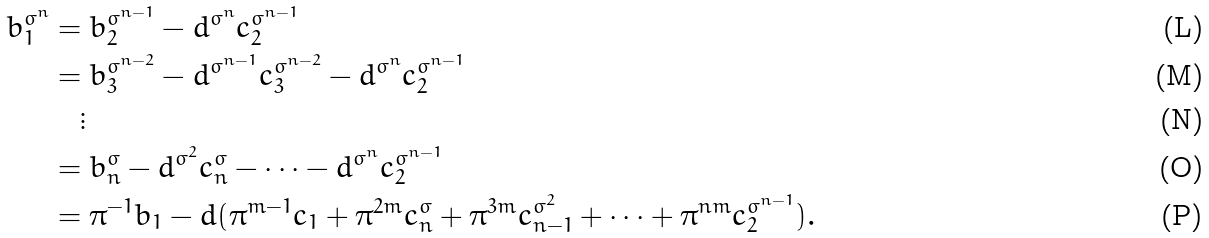<formula> <loc_0><loc_0><loc_500><loc_500>b _ { 1 } ^ { \sigma ^ { n } } & = b _ { 2 } ^ { \sigma ^ { n - 1 } } - d ^ { \sigma ^ { n } } c _ { 2 } ^ { \sigma ^ { n - 1 } } \\ & = b _ { 3 } ^ { \sigma ^ { n - 2 } } - d ^ { \sigma ^ { n - 1 } } c _ { 3 } ^ { \sigma ^ { n - 2 } } - d ^ { \sigma ^ { n } } c _ { 2 } ^ { \sigma ^ { n - 1 } } \\ & \quad \vdots \\ & = b _ { n } ^ { \sigma } - d ^ { \sigma ^ { 2 } } c _ { n } ^ { \sigma } - \cdots - d ^ { \sigma ^ { n } } c _ { 2 } ^ { \sigma ^ { n - 1 } } \\ & = \pi ^ { - 1 } b _ { 1 } - d ( \pi ^ { m - 1 } c _ { 1 } + \pi ^ { 2 m } c _ { n } ^ { \sigma } + \pi ^ { 3 m } c _ { n - 1 } ^ { \sigma ^ { 2 } } + \cdots + \pi ^ { n m } c _ { 2 } ^ { \sigma ^ { n - 1 } } ) .</formula> 